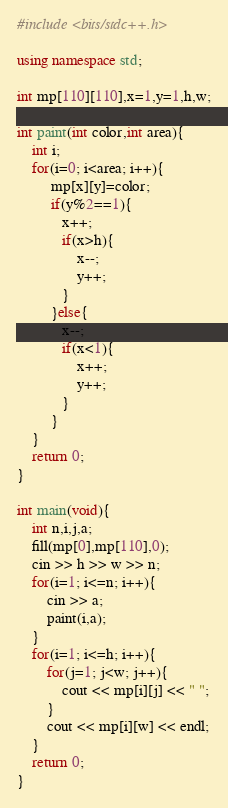<code> <loc_0><loc_0><loc_500><loc_500><_C++_>#include <bits/stdc++.h>

using namespace std;

int mp[110][110],x=1,y=1,h,w;

int paint(int color,int area){
	int i;
	for(i=0; i<area; i++){
		 mp[x][y]=color;
		 if(y%2==1){
		 	x++;
		 	if(x>h){
		 		x--;
		 		y++;
		 	}
		 }else{
		 	x--;
		 	if(x<1){
		 		x++;
		 		y++;
		 	}
		 }
	}
	return 0;
}

int main(void){
	int n,i,j,a;
	fill(mp[0],mp[110],0);
	cin >> h >> w >> n;
	for(i=1; i<=n; i++){
		cin >> a;
		paint(i,a);
	}
	for(i=1; i<=h; i++){
		for(j=1; j<w; j++){
			cout << mp[i][j] << " ";
		}
		cout << mp[i][w] << endl;
	}
	return 0;
}</code> 